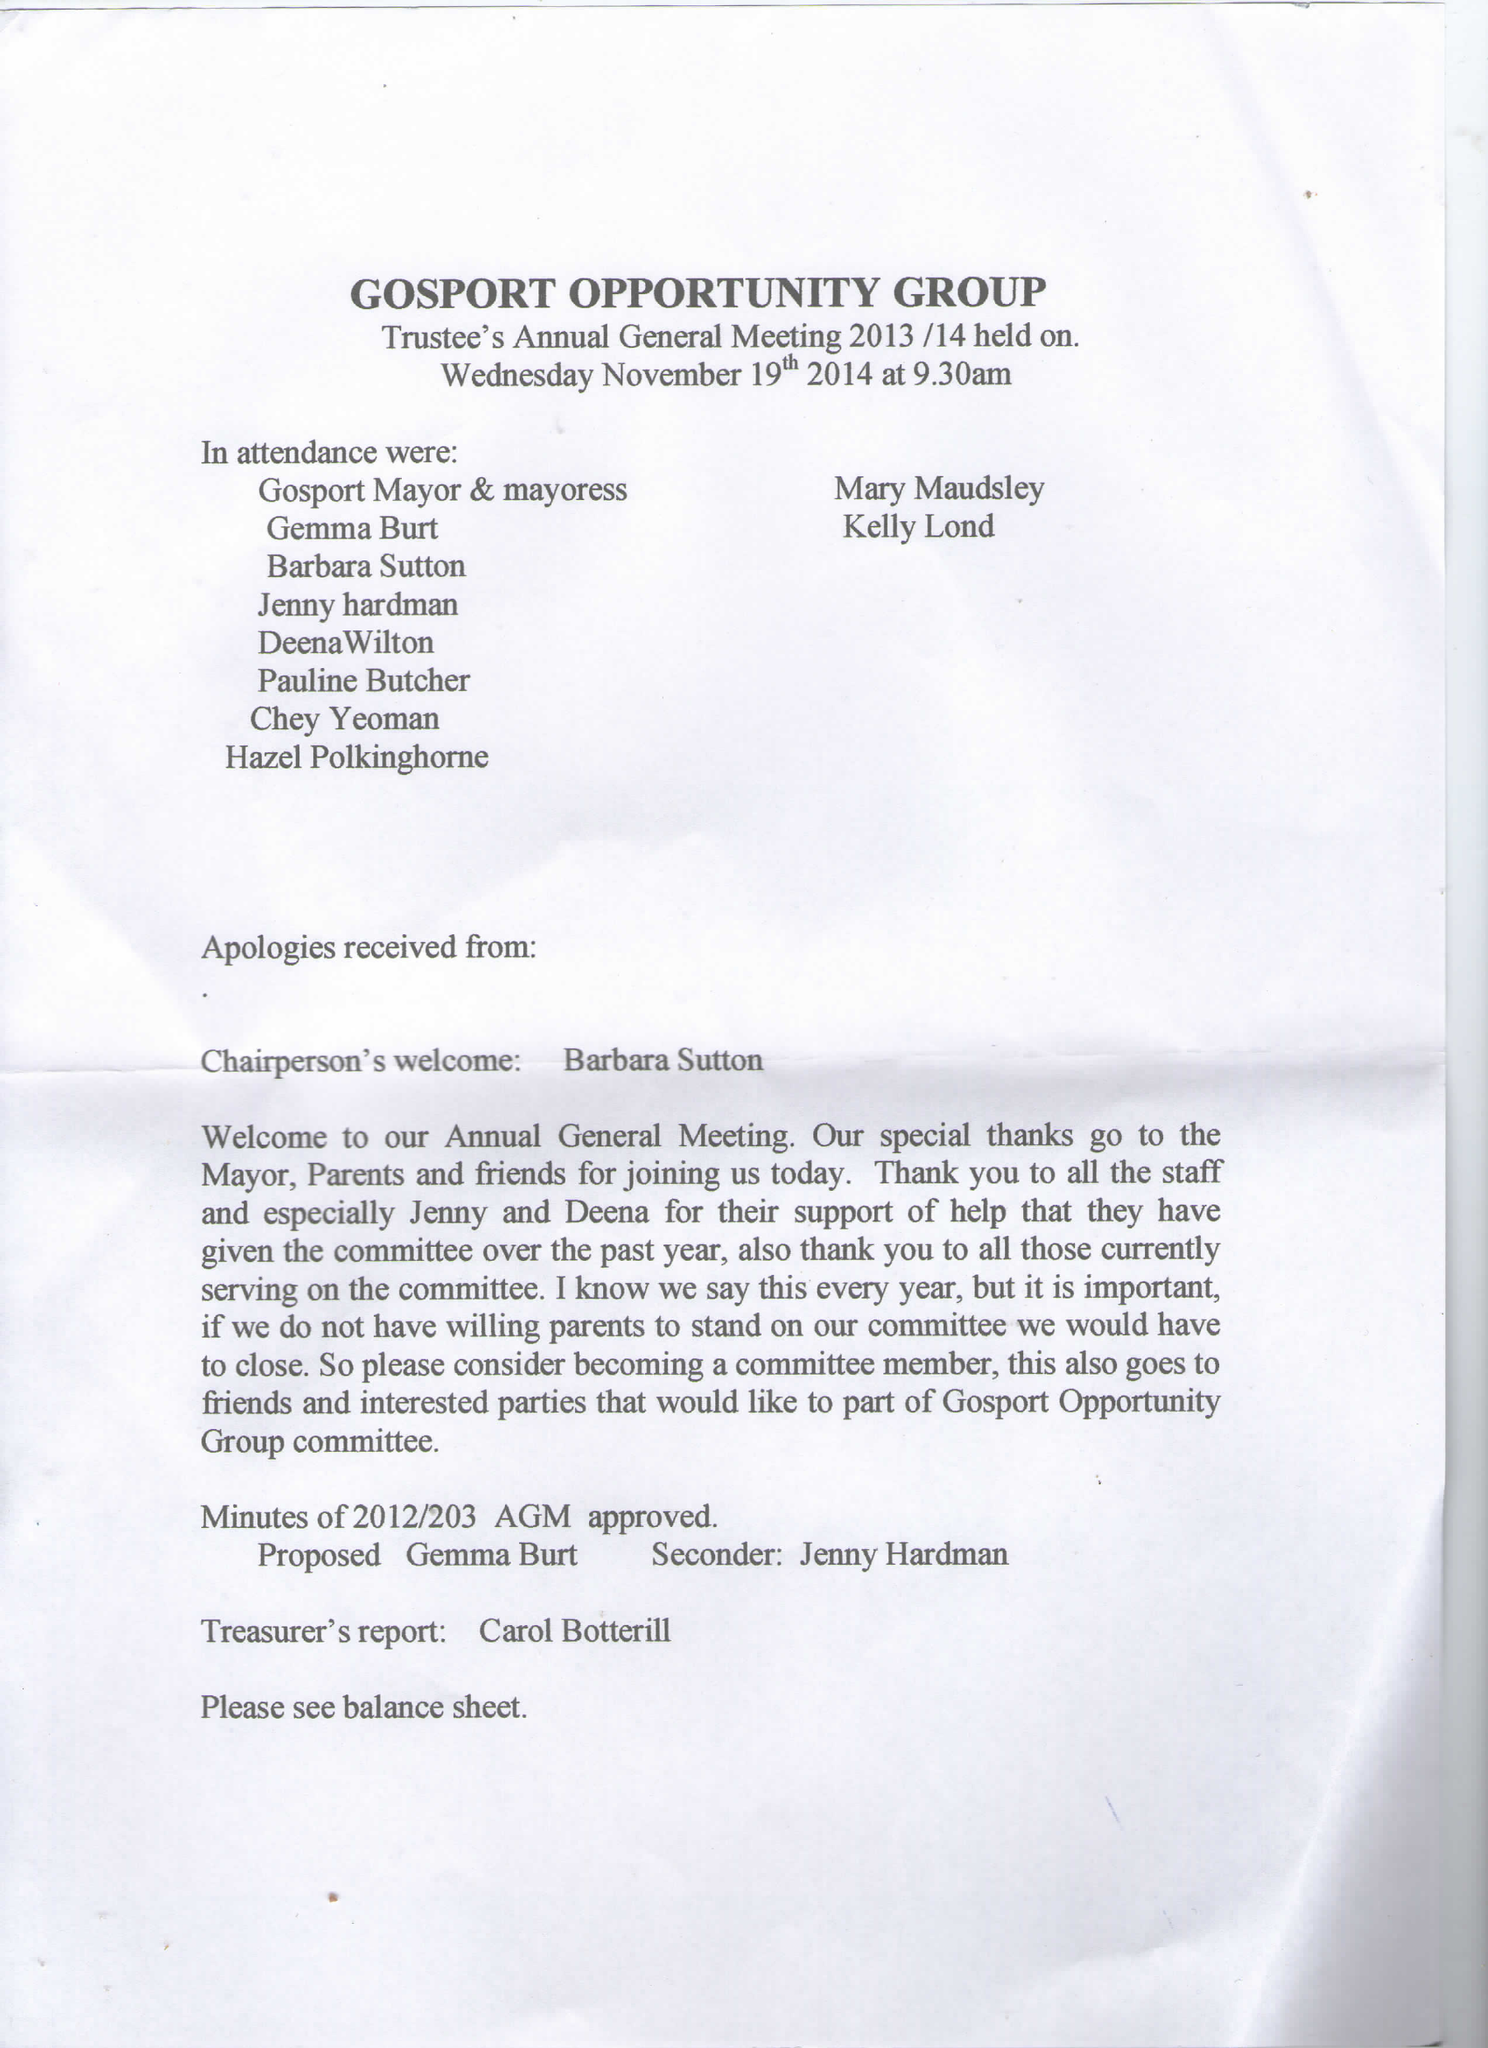What is the value for the address__postcode?
Answer the question using a single word or phrase. PO13 0BE 